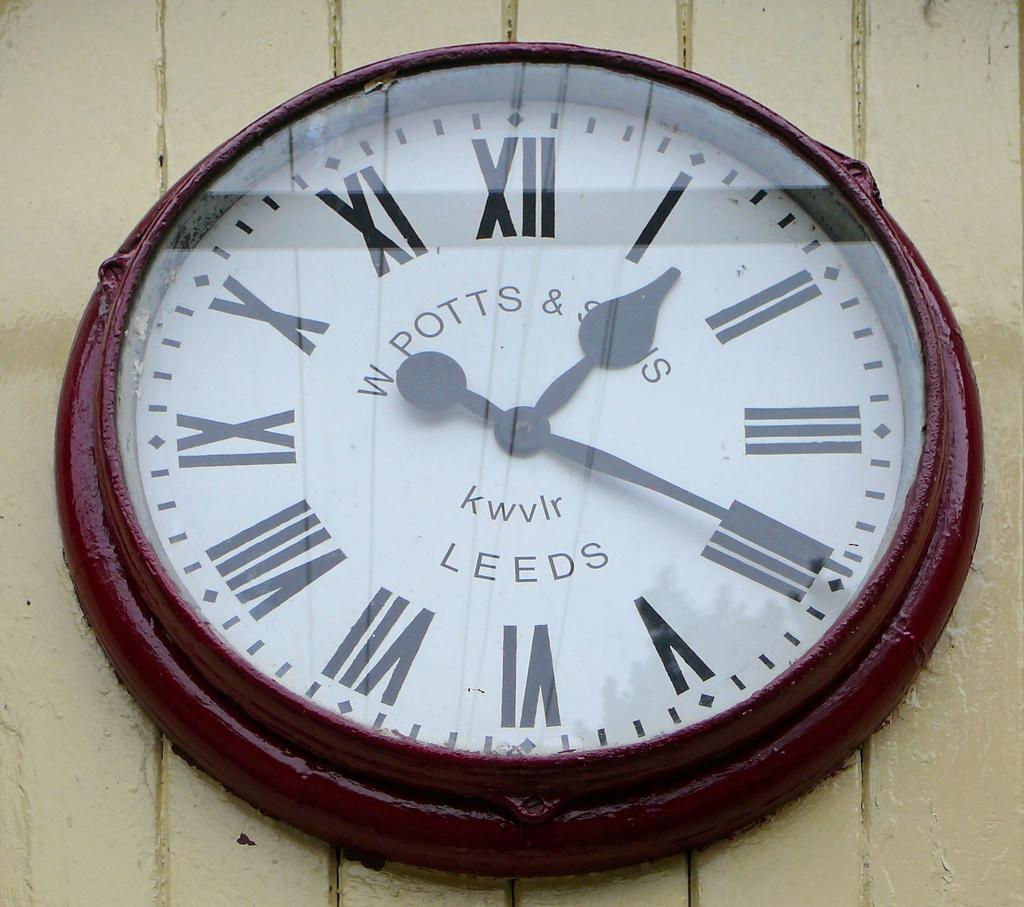Provide a one-sentence caption for the provided image. A W Potts and Son's clock displaying the time. 